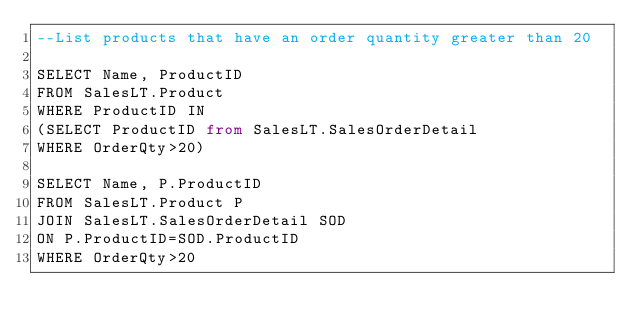Convert code to text. <code><loc_0><loc_0><loc_500><loc_500><_SQL_>--List products that have an order quantity greater than 20

SELECT Name, ProductID
FROM SalesLT.Product
WHERE ProductID IN
(SELECT ProductID from SalesLT.SalesOrderDetail
WHERE OrderQty>20)

SELECT Name, P.ProductID
FROM SalesLT.Product P
JOIN SalesLT.SalesOrderDetail SOD
ON P.ProductID=SOD.ProductID
WHERE OrderQty>20</code> 